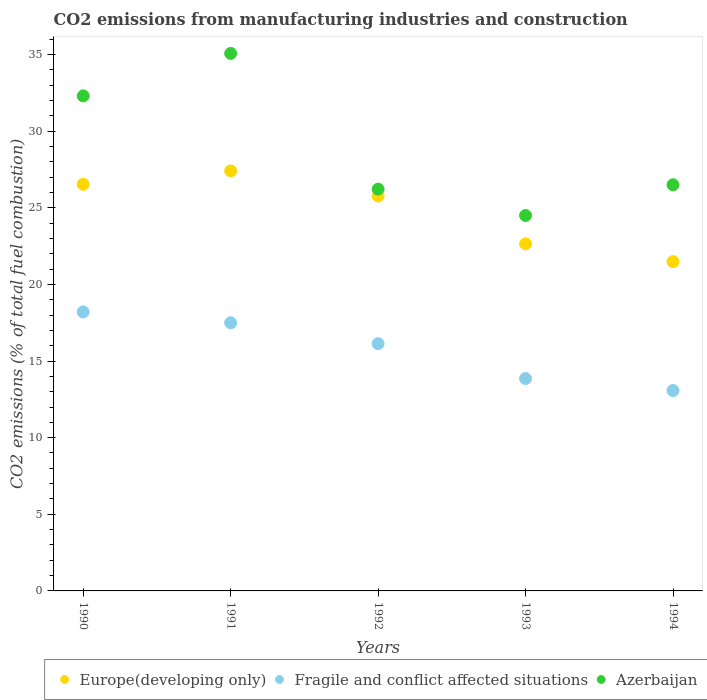How many different coloured dotlines are there?
Keep it short and to the point. 3. What is the amount of CO2 emitted in Europe(developing only) in 1991?
Your answer should be very brief. 27.41. Across all years, what is the maximum amount of CO2 emitted in Azerbaijan?
Your answer should be compact. 35.07. Across all years, what is the minimum amount of CO2 emitted in Europe(developing only)?
Ensure brevity in your answer.  21.49. In which year was the amount of CO2 emitted in Europe(developing only) maximum?
Keep it short and to the point. 1991. What is the total amount of CO2 emitted in Europe(developing only) in the graph?
Offer a very short reply. 123.84. What is the difference between the amount of CO2 emitted in Europe(developing only) in 1991 and that in 1993?
Your answer should be compact. 4.76. What is the difference between the amount of CO2 emitted in Azerbaijan in 1991 and the amount of CO2 emitted in Fragile and conflict affected situations in 1990?
Offer a terse response. 16.87. What is the average amount of CO2 emitted in Fragile and conflict affected situations per year?
Provide a short and direct response. 15.75. In the year 1993, what is the difference between the amount of CO2 emitted in Azerbaijan and amount of CO2 emitted in Europe(developing only)?
Offer a terse response. 1.85. In how many years, is the amount of CO2 emitted in Europe(developing only) greater than 7 %?
Offer a terse response. 5. What is the ratio of the amount of CO2 emitted in Azerbaijan in 1992 to that in 1993?
Ensure brevity in your answer.  1.07. Is the difference between the amount of CO2 emitted in Azerbaijan in 1991 and 1992 greater than the difference between the amount of CO2 emitted in Europe(developing only) in 1991 and 1992?
Your answer should be very brief. Yes. What is the difference between the highest and the second highest amount of CO2 emitted in Azerbaijan?
Your answer should be compact. 2.77. What is the difference between the highest and the lowest amount of CO2 emitted in Fragile and conflict affected situations?
Your answer should be very brief. 5.13. In how many years, is the amount of CO2 emitted in Azerbaijan greater than the average amount of CO2 emitted in Azerbaijan taken over all years?
Offer a terse response. 2. Is the sum of the amount of CO2 emitted in Azerbaijan in 1991 and 1993 greater than the maximum amount of CO2 emitted in Fragile and conflict affected situations across all years?
Your answer should be very brief. Yes. How many dotlines are there?
Your answer should be compact. 3. What is the difference between two consecutive major ticks on the Y-axis?
Your answer should be compact. 5. Where does the legend appear in the graph?
Your response must be concise. Bottom right. How many legend labels are there?
Provide a short and direct response. 3. What is the title of the graph?
Give a very brief answer. CO2 emissions from manufacturing industries and construction. Does "Dominica" appear as one of the legend labels in the graph?
Your response must be concise. No. What is the label or title of the Y-axis?
Your answer should be compact. CO2 emissions (% of total fuel combustion). What is the CO2 emissions (% of total fuel combustion) in Europe(developing only) in 1990?
Your answer should be very brief. 26.53. What is the CO2 emissions (% of total fuel combustion) of Fragile and conflict affected situations in 1990?
Provide a short and direct response. 18.2. What is the CO2 emissions (% of total fuel combustion) in Azerbaijan in 1990?
Make the answer very short. 32.3. What is the CO2 emissions (% of total fuel combustion) in Europe(developing only) in 1991?
Keep it short and to the point. 27.41. What is the CO2 emissions (% of total fuel combustion) of Fragile and conflict affected situations in 1991?
Your answer should be very brief. 17.5. What is the CO2 emissions (% of total fuel combustion) in Azerbaijan in 1991?
Offer a terse response. 35.07. What is the CO2 emissions (% of total fuel combustion) in Europe(developing only) in 1992?
Ensure brevity in your answer.  25.77. What is the CO2 emissions (% of total fuel combustion) in Fragile and conflict affected situations in 1992?
Your answer should be very brief. 16.13. What is the CO2 emissions (% of total fuel combustion) in Azerbaijan in 1992?
Provide a short and direct response. 26.22. What is the CO2 emissions (% of total fuel combustion) of Europe(developing only) in 1993?
Your response must be concise. 22.65. What is the CO2 emissions (% of total fuel combustion) in Fragile and conflict affected situations in 1993?
Provide a short and direct response. 13.86. What is the CO2 emissions (% of total fuel combustion) of Azerbaijan in 1993?
Give a very brief answer. 24.5. What is the CO2 emissions (% of total fuel combustion) in Europe(developing only) in 1994?
Ensure brevity in your answer.  21.49. What is the CO2 emissions (% of total fuel combustion) of Fragile and conflict affected situations in 1994?
Your answer should be very brief. 13.07. What is the CO2 emissions (% of total fuel combustion) in Azerbaijan in 1994?
Your response must be concise. 26.5. Across all years, what is the maximum CO2 emissions (% of total fuel combustion) in Europe(developing only)?
Offer a very short reply. 27.41. Across all years, what is the maximum CO2 emissions (% of total fuel combustion) in Fragile and conflict affected situations?
Give a very brief answer. 18.2. Across all years, what is the maximum CO2 emissions (% of total fuel combustion) in Azerbaijan?
Offer a very short reply. 35.07. Across all years, what is the minimum CO2 emissions (% of total fuel combustion) of Europe(developing only)?
Your response must be concise. 21.49. Across all years, what is the minimum CO2 emissions (% of total fuel combustion) of Fragile and conflict affected situations?
Make the answer very short. 13.07. Across all years, what is the minimum CO2 emissions (% of total fuel combustion) of Azerbaijan?
Offer a terse response. 24.5. What is the total CO2 emissions (% of total fuel combustion) of Europe(developing only) in the graph?
Provide a short and direct response. 123.84. What is the total CO2 emissions (% of total fuel combustion) in Fragile and conflict affected situations in the graph?
Provide a short and direct response. 78.77. What is the total CO2 emissions (% of total fuel combustion) in Azerbaijan in the graph?
Make the answer very short. 144.59. What is the difference between the CO2 emissions (% of total fuel combustion) in Europe(developing only) in 1990 and that in 1991?
Your answer should be compact. -0.87. What is the difference between the CO2 emissions (% of total fuel combustion) of Fragile and conflict affected situations in 1990 and that in 1991?
Ensure brevity in your answer.  0.71. What is the difference between the CO2 emissions (% of total fuel combustion) of Azerbaijan in 1990 and that in 1991?
Offer a very short reply. -2.77. What is the difference between the CO2 emissions (% of total fuel combustion) of Europe(developing only) in 1990 and that in 1992?
Provide a succinct answer. 0.76. What is the difference between the CO2 emissions (% of total fuel combustion) in Fragile and conflict affected situations in 1990 and that in 1992?
Your answer should be compact. 2.07. What is the difference between the CO2 emissions (% of total fuel combustion) in Azerbaijan in 1990 and that in 1992?
Provide a short and direct response. 6.09. What is the difference between the CO2 emissions (% of total fuel combustion) of Europe(developing only) in 1990 and that in 1993?
Keep it short and to the point. 3.89. What is the difference between the CO2 emissions (% of total fuel combustion) of Fragile and conflict affected situations in 1990 and that in 1993?
Make the answer very short. 4.35. What is the difference between the CO2 emissions (% of total fuel combustion) of Azerbaijan in 1990 and that in 1993?
Ensure brevity in your answer.  7.81. What is the difference between the CO2 emissions (% of total fuel combustion) of Europe(developing only) in 1990 and that in 1994?
Keep it short and to the point. 5.04. What is the difference between the CO2 emissions (% of total fuel combustion) of Fragile and conflict affected situations in 1990 and that in 1994?
Keep it short and to the point. 5.13. What is the difference between the CO2 emissions (% of total fuel combustion) of Azerbaijan in 1990 and that in 1994?
Make the answer very short. 5.8. What is the difference between the CO2 emissions (% of total fuel combustion) of Europe(developing only) in 1991 and that in 1992?
Offer a terse response. 1.64. What is the difference between the CO2 emissions (% of total fuel combustion) of Fragile and conflict affected situations in 1991 and that in 1992?
Provide a succinct answer. 1.36. What is the difference between the CO2 emissions (% of total fuel combustion) in Azerbaijan in 1991 and that in 1992?
Provide a short and direct response. 8.86. What is the difference between the CO2 emissions (% of total fuel combustion) of Europe(developing only) in 1991 and that in 1993?
Ensure brevity in your answer.  4.76. What is the difference between the CO2 emissions (% of total fuel combustion) in Fragile and conflict affected situations in 1991 and that in 1993?
Provide a succinct answer. 3.64. What is the difference between the CO2 emissions (% of total fuel combustion) in Azerbaijan in 1991 and that in 1993?
Give a very brief answer. 10.57. What is the difference between the CO2 emissions (% of total fuel combustion) of Europe(developing only) in 1991 and that in 1994?
Ensure brevity in your answer.  5.92. What is the difference between the CO2 emissions (% of total fuel combustion) of Fragile and conflict affected situations in 1991 and that in 1994?
Offer a terse response. 4.42. What is the difference between the CO2 emissions (% of total fuel combustion) of Azerbaijan in 1991 and that in 1994?
Ensure brevity in your answer.  8.57. What is the difference between the CO2 emissions (% of total fuel combustion) in Europe(developing only) in 1992 and that in 1993?
Your answer should be compact. 3.12. What is the difference between the CO2 emissions (% of total fuel combustion) of Fragile and conflict affected situations in 1992 and that in 1993?
Provide a succinct answer. 2.28. What is the difference between the CO2 emissions (% of total fuel combustion) of Azerbaijan in 1992 and that in 1993?
Your response must be concise. 1.72. What is the difference between the CO2 emissions (% of total fuel combustion) in Europe(developing only) in 1992 and that in 1994?
Your answer should be very brief. 4.28. What is the difference between the CO2 emissions (% of total fuel combustion) of Fragile and conflict affected situations in 1992 and that in 1994?
Your response must be concise. 3.06. What is the difference between the CO2 emissions (% of total fuel combustion) of Azerbaijan in 1992 and that in 1994?
Offer a very short reply. -0.29. What is the difference between the CO2 emissions (% of total fuel combustion) in Europe(developing only) in 1993 and that in 1994?
Offer a terse response. 1.16. What is the difference between the CO2 emissions (% of total fuel combustion) of Fragile and conflict affected situations in 1993 and that in 1994?
Your answer should be very brief. 0.78. What is the difference between the CO2 emissions (% of total fuel combustion) of Azerbaijan in 1993 and that in 1994?
Your answer should be compact. -2. What is the difference between the CO2 emissions (% of total fuel combustion) in Europe(developing only) in 1990 and the CO2 emissions (% of total fuel combustion) in Fragile and conflict affected situations in 1991?
Your response must be concise. 9.03. What is the difference between the CO2 emissions (% of total fuel combustion) in Europe(developing only) in 1990 and the CO2 emissions (% of total fuel combustion) in Azerbaijan in 1991?
Keep it short and to the point. -8.54. What is the difference between the CO2 emissions (% of total fuel combustion) of Fragile and conflict affected situations in 1990 and the CO2 emissions (% of total fuel combustion) of Azerbaijan in 1991?
Provide a short and direct response. -16.87. What is the difference between the CO2 emissions (% of total fuel combustion) in Europe(developing only) in 1990 and the CO2 emissions (% of total fuel combustion) in Fragile and conflict affected situations in 1992?
Make the answer very short. 10.4. What is the difference between the CO2 emissions (% of total fuel combustion) in Europe(developing only) in 1990 and the CO2 emissions (% of total fuel combustion) in Azerbaijan in 1992?
Provide a short and direct response. 0.31. What is the difference between the CO2 emissions (% of total fuel combustion) in Fragile and conflict affected situations in 1990 and the CO2 emissions (% of total fuel combustion) in Azerbaijan in 1992?
Provide a short and direct response. -8.01. What is the difference between the CO2 emissions (% of total fuel combustion) of Europe(developing only) in 1990 and the CO2 emissions (% of total fuel combustion) of Fragile and conflict affected situations in 1993?
Ensure brevity in your answer.  12.67. What is the difference between the CO2 emissions (% of total fuel combustion) in Europe(developing only) in 1990 and the CO2 emissions (% of total fuel combustion) in Azerbaijan in 1993?
Give a very brief answer. 2.03. What is the difference between the CO2 emissions (% of total fuel combustion) of Fragile and conflict affected situations in 1990 and the CO2 emissions (% of total fuel combustion) of Azerbaijan in 1993?
Make the answer very short. -6.29. What is the difference between the CO2 emissions (% of total fuel combustion) in Europe(developing only) in 1990 and the CO2 emissions (% of total fuel combustion) in Fragile and conflict affected situations in 1994?
Give a very brief answer. 13.46. What is the difference between the CO2 emissions (% of total fuel combustion) of Europe(developing only) in 1990 and the CO2 emissions (% of total fuel combustion) of Azerbaijan in 1994?
Give a very brief answer. 0.03. What is the difference between the CO2 emissions (% of total fuel combustion) in Fragile and conflict affected situations in 1990 and the CO2 emissions (% of total fuel combustion) in Azerbaijan in 1994?
Make the answer very short. -8.3. What is the difference between the CO2 emissions (% of total fuel combustion) in Europe(developing only) in 1991 and the CO2 emissions (% of total fuel combustion) in Fragile and conflict affected situations in 1992?
Your response must be concise. 11.27. What is the difference between the CO2 emissions (% of total fuel combustion) of Europe(developing only) in 1991 and the CO2 emissions (% of total fuel combustion) of Azerbaijan in 1992?
Offer a terse response. 1.19. What is the difference between the CO2 emissions (% of total fuel combustion) of Fragile and conflict affected situations in 1991 and the CO2 emissions (% of total fuel combustion) of Azerbaijan in 1992?
Your answer should be very brief. -8.72. What is the difference between the CO2 emissions (% of total fuel combustion) in Europe(developing only) in 1991 and the CO2 emissions (% of total fuel combustion) in Fragile and conflict affected situations in 1993?
Provide a succinct answer. 13.55. What is the difference between the CO2 emissions (% of total fuel combustion) of Europe(developing only) in 1991 and the CO2 emissions (% of total fuel combustion) of Azerbaijan in 1993?
Offer a terse response. 2.91. What is the difference between the CO2 emissions (% of total fuel combustion) of Fragile and conflict affected situations in 1991 and the CO2 emissions (% of total fuel combustion) of Azerbaijan in 1993?
Your answer should be very brief. -7. What is the difference between the CO2 emissions (% of total fuel combustion) of Europe(developing only) in 1991 and the CO2 emissions (% of total fuel combustion) of Fragile and conflict affected situations in 1994?
Ensure brevity in your answer.  14.33. What is the difference between the CO2 emissions (% of total fuel combustion) in Europe(developing only) in 1991 and the CO2 emissions (% of total fuel combustion) in Azerbaijan in 1994?
Provide a short and direct response. 0.9. What is the difference between the CO2 emissions (% of total fuel combustion) in Fragile and conflict affected situations in 1991 and the CO2 emissions (% of total fuel combustion) in Azerbaijan in 1994?
Your response must be concise. -9.01. What is the difference between the CO2 emissions (% of total fuel combustion) of Europe(developing only) in 1992 and the CO2 emissions (% of total fuel combustion) of Fragile and conflict affected situations in 1993?
Offer a very short reply. 11.91. What is the difference between the CO2 emissions (% of total fuel combustion) in Europe(developing only) in 1992 and the CO2 emissions (% of total fuel combustion) in Azerbaijan in 1993?
Your response must be concise. 1.27. What is the difference between the CO2 emissions (% of total fuel combustion) of Fragile and conflict affected situations in 1992 and the CO2 emissions (% of total fuel combustion) of Azerbaijan in 1993?
Keep it short and to the point. -8.36. What is the difference between the CO2 emissions (% of total fuel combustion) in Europe(developing only) in 1992 and the CO2 emissions (% of total fuel combustion) in Fragile and conflict affected situations in 1994?
Make the answer very short. 12.69. What is the difference between the CO2 emissions (% of total fuel combustion) of Europe(developing only) in 1992 and the CO2 emissions (% of total fuel combustion) of Azerbaijan in 1994?
Offer a terse response. -0.74. What is the difference between the CO2 emissions (% of total fuel combustion) in Fragile and conflict affected situations in 1992 and the CO2 emissions (% of total fuel combustion) in Azerbaijan in 1994?
Provide a succinct answer. -10.37. What is the difference between the CO2 emissions (% of total fuel combustion) in Europe(developing only) in 1993 and the CO2 emissions (% of total fuel combustion) in Fragile and conflict affected situations in 1994?
Your answer should be very brief. 9.57. What is the difference between the CO2 emissions (% of total fuel combustion) of Europe(developing only) in 1993 and the CO2 emissions (% of total fuel combustion) of Azerbaijan in 1994?
Give a very brief answer. -3.86. What is the difference between the CO2 emissions (% of total fuel combustion) of Fragile and conflict affected situations in 1993 and the CO2 emissions (% of total fuel combustion) of Azerbaijan in 1994?
Offer a terse response. -12.64. What is the average CO2 emissions (% of total fuel combustion) of Europe(developing only) per year?
Offer a very short reply. 24.77. What is the average CO2 emissions (% of total fuel combustion) of Fragile and conflict affected situations per year?
Provide a short and direct response. 15.75. What is the average CO2 emissions (% of total fuel combustion) of Azerbaijan per year?
Ensure brevity in your answer.  28.92. In the year 1990, what is the difference between the CO2 emissions (% of total fuel combustion) of Europe(developing only) and CO2 emissions (% of total fuel combustion) of Fragile and conflict affected situations?
Your answer should be very brief. 8.33. In the year 1990, what is the difference between the CO2 emissions (% of total fuel combustion) in Europe(developing only) and CO2 emissions (% of total fuel combustion) in Azerbaijan?
Ensure brevity in your answer.  -5.77. In the year 1990, what is the difference between the CO2 emissions (% of total fuel combustion) in Fragile and conflict affected situations and CO2 emissions (% of total fuel combustion) in Azerbaijan?
Provide a short and direct response. -14.1. In the year 1991, what is the difference between the CO2 emissions (% of total fuel combustion) in Europe(developing only) and CO2 emissions (% of total fuel combustion) in Fragile and conflict affected situations?
Ensure brevity in your answer.  9.91. In the year 1991, what is the difference between the CO2 emissions (% of total fuel combustion) of Europe(developing only) and CO2 emissions (% of total fuel combustion) of Azerbaijan?
Your answer should be very brief. -7.67. In the year 1991, what is the difference between the CO2 emissions (% of total fuel combustion) of Fragile and conflict affected situations and CO2 emissions (% of total fuel combustion) of Azerbaijan?
Your answer should be compact. -17.58. In the year 1992, what is the difference between the CO2 emissions (% of total fuel combustion) in Europe(developing only) and CO2 emissions (% of total fuel combustion) in Fragile and conflict affected situations?
Your response must be concise. 9.63. In the year 1992, what is the difference between the CO2 emissions (% of total fuel combustion) in Europe(developing only) and CO2 emissions (% of total fuel combustion) in Azerbaijan?
Provide a short and direct response. -0.45. In the year 1992, what is the difference between the CO2 emissions (% of total fuel combustion) of Fragile and conflict affected situations and CO2 emissions (% of total fuel combustion) of Azerbaijan?
Offer a terse response. -10.08. In the year 1993, what is the difference between the CO2 emissions (% of total fuel combustion) of Europe(developing only) and CO2 emissions (% of total fuel combustion) of Fragile and conflict affected situations?
Your answer should be very brief. 8.79. In the year 1993, what is the difference between the CO2 emissions (% of total fuel combustion) in Europe(developing only) and CO2 emissions (% of total fuel combustion) in Azerbaijan?
Make the answer very short. -1.85. In the year 1993, what is the difference between the CO2 emissions (% of total fuel combustion) in Fragile and conflict affected situations and CO2 emissions (% of total fuel combustion) in Azerbaijan?
Ensure brevity in your answer.  -10.64. In the year 1994, what is the difference between the CO2 emissions (% of total fuel combustion) of Europe(developing only) and CO2 emissions (% of total fuel combustion) of Fragile and conflict affected situations?
Your response must be concise. 8.41. In the year 1994, what is the difference between the CO2 emissions (% of total fuel combustion) in Europe(developing only) and CO2 emissions (% of total fuel combustion) in Azerbaijan?
Give a very brief answer. -5.01. In the year 1994, what is the difference between the CO2 emissions (% of total fuel combustion) in Fragile and conflict affected situations and CO2 emissions (% of total fuel combustion) in Azerbaijan?
Your response must be concise. -13.43. What is the ratio of the CO2 emissions (% of total fuel combustion) of Europe(developing only) in 1990 to that in 1991?
Give a very brief answer. 0.97. What is the ratio of the CO2 emissions (% of total fuel combustion) in Fragile and conflict affected situations in 1990 to that in 1991?
Your answer should be compact. 1.04. What is the ratio of the CO2 emissions (% of total fuel combustion) of Azerbaijan in 1990 to that in 1991?
Your response must be concise. 0.92. What is the ratio of the CO2 emissions (% of total fuel combustion) of Europe(developing only) in 1990 to that in 1992?
Offer a terse response. 1.03. What is the ratio of the CO2 emissions (% of total fuel combustion) in Fragile and conflict affected situations in 1990 to that in 1992?
Your answer should be compact. 1.13. What is the ratio of the CO2 emissions (% of total fuel combustion) of Azerbaijan in 1990 to that in 1992?
Offer a very short reply. 1.23. What is the ratio of the CO2 emissions (% of total fuel combustion) of Europe(developing only) in 1990 to that in 1993?
Your response must be concise. 1.17. What is the ratio of the CO2 emissions (% of total fuel combustion) of Fragile and conflict affected situations in 1990 to that in 1993?
Provide a short and direct response. 1.31. What is the ratio of the CO2 emissions (% of total fuel combustion) in Azerbaijan in 1990 to that in 1993?
Ensure brevity in your answer.  1.32. What is the ratio of the CO2 emissions (% of total fuel combustion) of Europe(developing only) in 1990 to that in 1994?
Ensure brevity in your answer.  1.23. What is the ratio of the CO2 emissions (% of total fuel combustion) in Fragile and conflict affected situations in 1990 to that in 1994?
Keep it short and to the point. 1.39. What is the ratio of the CO2 emissions (% of total fuel combustion) in Azerbaijan in 1990 to that in 1994?
Your response must be concise. 1.22. What is the ratio of the CO2 emissions (% of total fuel combustion) of Europe(developing only) in 1991 to that in 1992?
Ensure brevity in your answer.  1.06. What is the ratio of the CO2 emissions (% of total fuel combustion) of Fragile and conflict affected situations in 1991 to that in 1992?
Your response must be concise. 1.08. What is the ratio of the CO2 emissions (% of total fuel combustion) in Azerbaijan in 1991 to that in 1992?
Ensure brevity in your answer.  1.34. What is the ratio of the CO2 emissions (% of total fuel combustion) in Europe(developing only) in 1991 to that in 1993?
Give a very brief answer. 1.21. What is the ratio of the CO2 emissions (% of total fuel combustion) of Fragile and conflict affected situations in 1991 to that in 1993?
Your answer should be compact. 1.26. What is the ratio of the CO2 emissions (% of total fuel combustion) in Azerbaijan in 1991 to that in 1993?
Give a very brief answer. 1.43. What is the ratio of the CO2 emissions (% of total fuel combustion) of Europe(developing only) in 1991 to that in 1994?
Provide a short and direct response. 1.28. What is the ratio of the CO2 emissions (% of total fuel combustion) in Fragile and conflict affected situations in 1991 to that in 1994?
Keep it short and to the point. 1.34. What is the ratio of the CO2 emissions (% of total fuel combustion) of Azerbaijan in 1991 to that in 1994?
Offer a terse response. 1.32. What is the ratio of the CO2 emissions (% of total fuel combustion) in Europe(developing only) in 1992 to that in 1993?
Your answer should be very brief. 1.14. What is the ratio of the CO2 emissions (% of total fuel combustion) of Fragile and conflict affected situations in 1992 to that in 1993?
Provide a succinct answer. 1.16. What is the ratio of the CO2 emissions (% of total fuel combustion) in Azerbaijan in 1992 to that in 1993?
Provide a succinct answer. 1.07. What is the ratio of the CO2 emissions (% of total fuel combustion) in Europe(developing only) in 1992 to that in 1994?
Give a very brief answer. 1.2. What is the ratio of the CO2 emissions (% of total fuel combustion) of Fragile and conflict affected situations in 1992 to that in 1994?
Your answer should be very brief. 1.23. What is the ratio of the CO2 emissions (% of total fuel combustion) of Azerbaijan in 1992 to that in 1994?
Give a very brief answer. 0.99. What is the ratio of the CO2 emissions (% of total fuel combustion) in Europe(developing only) in 1993 to that in 1994?
Your response must be concise. 1.05. What is the ratio of the CO2 emissions (% of total fuel combustion) in Fragile and conflict affected situations in 1993 to that in 1994?
Give a very brief answer. 1.06. What is the ratio of the CO2 emissions (% of total fuel combustion) in Azerbaijan in 1993 to that in 1994?
Your answer should be compact. 0.92. What is the difference between the highest and the second highest CO2 emissions (% of total fuel combustion) in Europe(developing only)?
Make the answer very short. 0.87. What is the difference between the highest and the second highest CO2 emissions (% of total fuel combustion) of Fragile and conflict affected situations?
Give a very brief answer. 0.71. What is the difference between the highest and the second highest CO2 emissions (% of total fuel combustion) of Azerbaijan?
Your answer should be compact. 2.77. What is the difference between the highest and the lowest CO2 emissions (% of total fuel combustion) in Europe(developing only)?
Provide a succinct answer. 5.92. What is the difference between the highest and the lowest CO2 emissions (% of total fuel combustion) of Fragile and conflict affected situations?
Your response must be concise. 5.13. What is the difference between the highest and the lowest CO2 emissions (% of total fuel combustion) in Azerbaijan?
Make the answer very short. 10.57. 